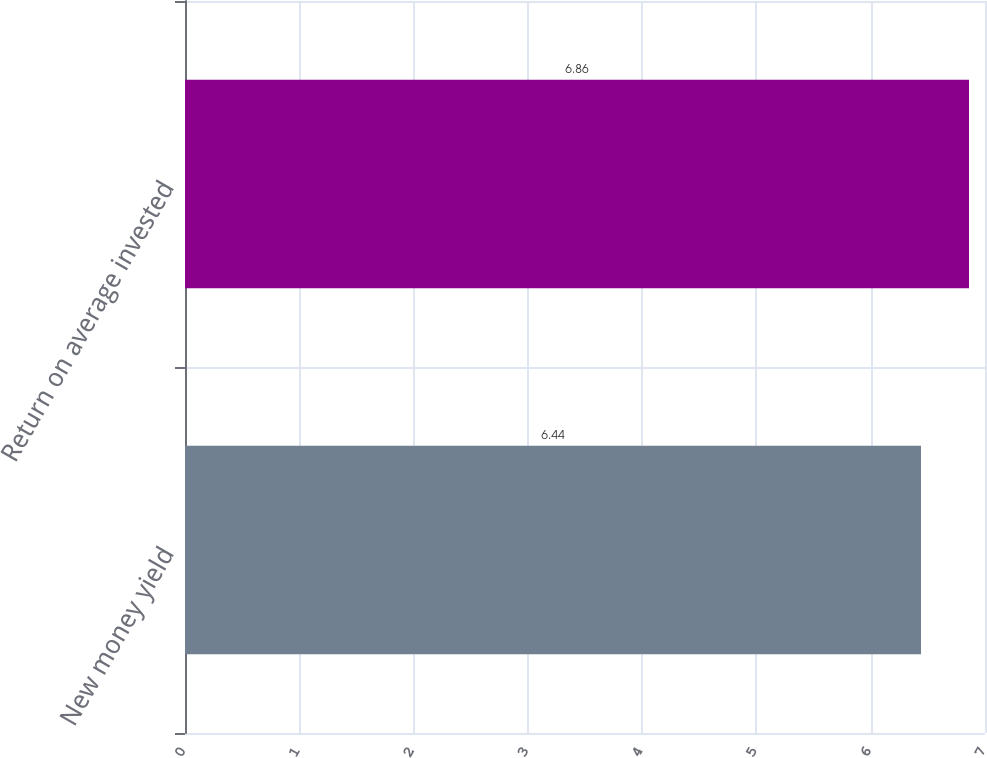Convert chart to OTSL. <chart><loc_0><loc_0><loc_500><loc_500><bar_chart><fcel>New money yield<fcel>Return on average invested<nl><fcel>6.44<fcel>6.86<nl></chart> 